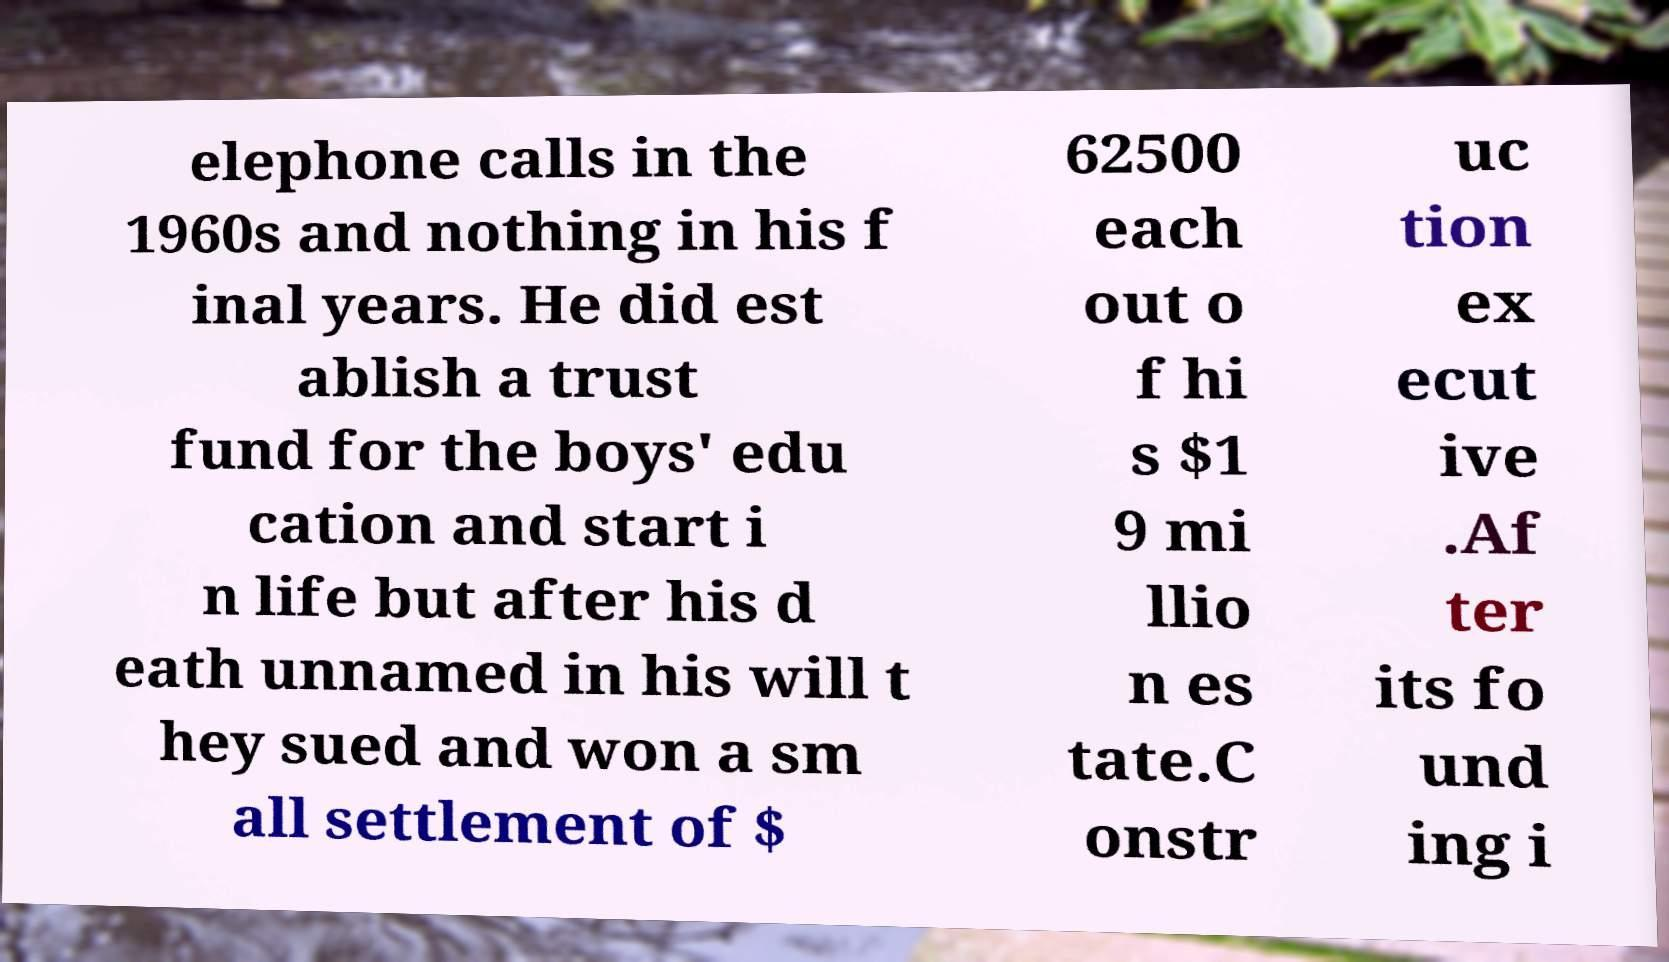For documentation purposes, I need the text within this image transcribed. Could you provide that? elephone calls in the 1960s and nothing in his f inal years. He did est ablish a trust fund for the boys' edu cation and start i n life but after his d eath unnamed in his will t hey sued and won a sm all settlement of $ 62500 each out o f hi s $1 9 mi llio n es tate.C onstr uc tion ex ecut ive .Af ter its fo und ing i 